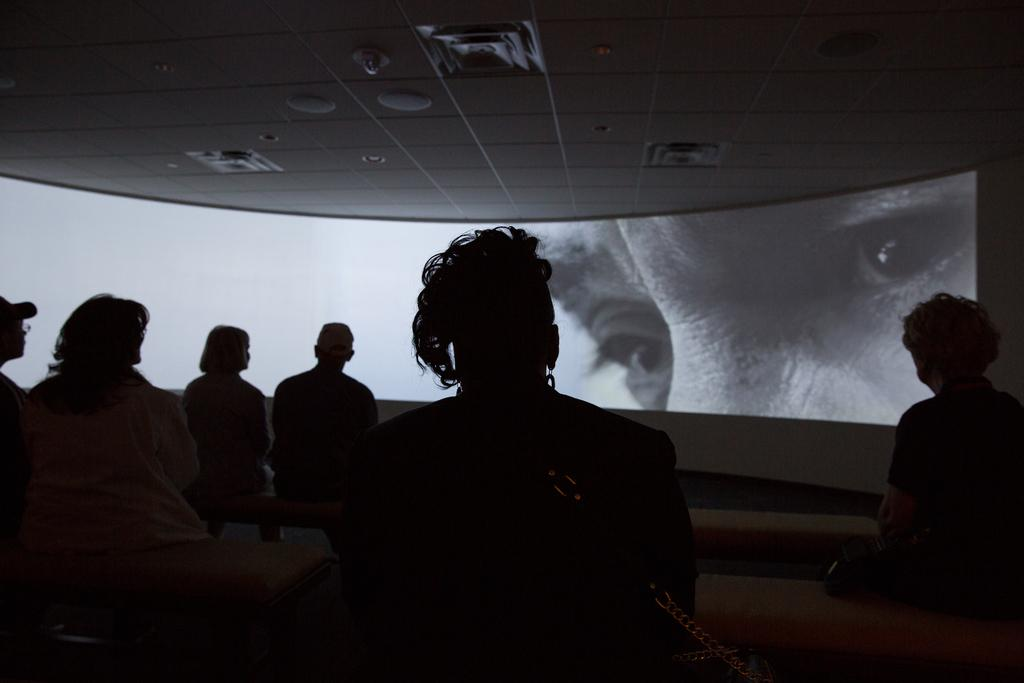What are the people in the image doing? There are persons sitting in the image. What can be seen in the background of the image? There is a screen in the background of the image. What is displayed on the screen? An image of a person is displayed on the screen. What type of fire can be seen in the image? There is no fire present in the image. How does the daughter contribute to the scene in the image? There is no mention of a daughter in the image, so it is not possible to answer that question. 